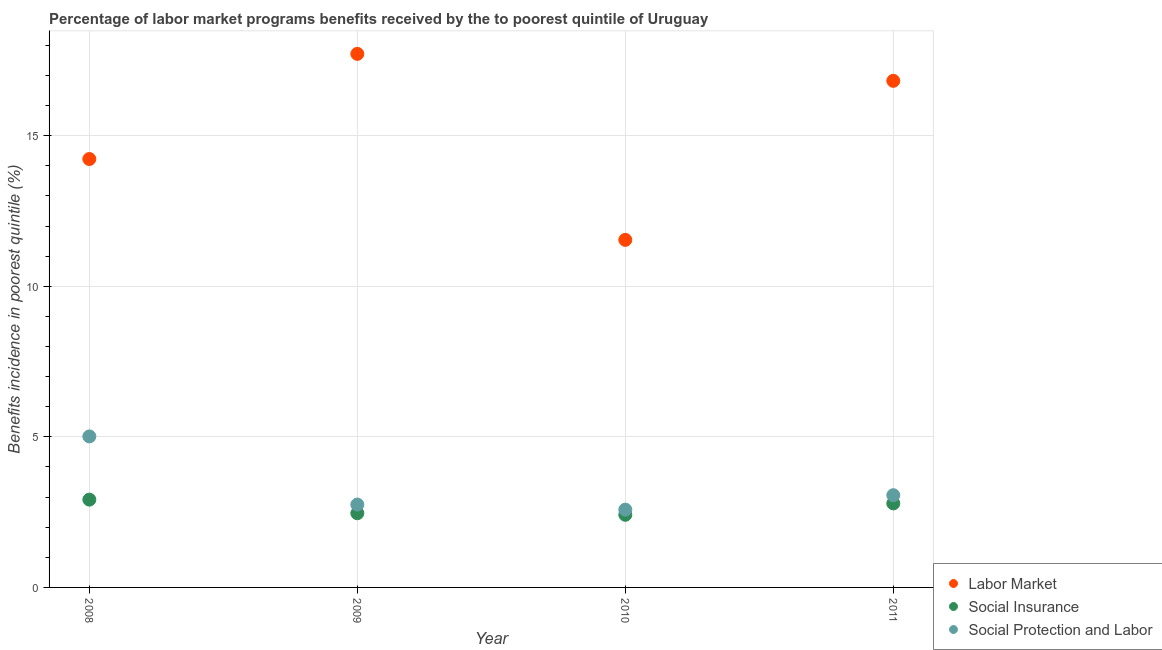How many different coloured dotlines are there?
Make the answer very short. 3. Is the number of dotlines equal to the number of legend labels?
Offer a terse response. Yes. What is the percentage of benefits received due to labor market programs in 2010?
Offer a terse response. 11.54. Across all years, what is the maximum percentage of benefits received due to social protection programs?
Your answer should be compact. 5.02. Across all years, what is the minimum percentage of benefits received due to social protection programs?
Offer a very short reply. 2.58. What is the total percentage of benefits received due to social protection programs in the graph?
Offer a very short reply. 13.41. What is the difference between the percentage of benefits received due to labor market programs in 2008 and that in 2010?
Your answer should be very brief. 2.68. What is the difference between the percentage of benefits received due to social insurance programs in 2010 and the percentage of benefits received due to social protection programs in 2009?
Your answer should be compact. -0.34. What is the average percentage of benefits received due to labor market programs per year?
Your response must be concise. 15.08. In the year 2011, what is the difference between the percentage of benefits received due to social insurance programs and percentage of benefits received due to social protection programs?
Your answer should be very brief. -0.27. In how many years, is the percentage of benefits received due to labor market programs greater than 4 %?
Your answer should be very brief. 4. What is the ratio of the percentage of benefits received due to social insurance programs in 2009 to that in 2010?
Keep it short and to the point. 1.02. Is the percentage of benefits received due to social protection programs in 2010 less than that in 2011?
Your answer should be compact. Yes. Is the difference between the percentage of benefits received due to social protection programs in 2008 and 2010 greater than the difference between the percentage of benefits received due to social insurance programs in 2008 and 2010?
Ensure brevity in your answer.  Yes. What is the difference between the highest and the second highest percentage of benefits received due to labor market programs?
Provide a short and direct response. 0.9. What is the difference between the highest and the lowest percentage of benefits received due to labor market programs?
Provide a succinct answer. 6.18. In how many years, is the percentage of benefits received due to labor market programs greater than the average percentage of benefits received due to labor market programs taken over all years?
Offer a terse response. 2. Is the sum of the percentage of benefits received due to social protection programs in 2008 and 2010 greater than the maximum percentage of benefits received due to labor market programs across all years?
Your response must be concise. No. Is it the case that in every year, the sum of the percentage of benefits received due to labor market programs and percentage of benefits received due to social insurance programs is greater than the percentage of benefits received due to social protection programs?
Your response must be concise. Yes. Is the percentage of benefits received due to social protection programs strictly greater than the percentage of benefits received due to social insurance programs over the years?
Make the answer very short. Yes. How many dotlines are there?
Your response must be concise. 3. How many years are there in the graph?
Your response must be concise. 4. Are the values on the major ticks of Y-axis written in scientific E-notation?
Make the answer very short. No. Does the graph contain grids?
Your answer should be very brief. Yes. Where does the legend appear in the graph?
Keep it short and to the point. Bottom right. How many legend labels are there?
Ensure brevity in your answer.  3. What is the title of the graph?
Your answer should be very brief. Percentage of labor market programs benefits received by the to poorest quintile of Uruguay. Does "Taxes on income" appear as one of the legend labels in the graph?
Provide a succinct answer. No. What is the label or title of the Y-axis?
Your answer should be compact. Benefits incidence in poorest quintile (%). What is the Benefits incidence in poorest quintile (%) of Labor Market in 2008?
Provide a succinct answer. 14.23. What is the Benefits incidence in poorest quintile (%) of Social Insurance in 2008?
Ensure brevity in your answer.  2.92. What is the Benefits incidence in poorest quintile (%) in Social Protection and Labor in 2008?
Offer a terse response. 5.02. What is the Benefits incidence in poorest quintile (%) of Labor Market in 2009?
Provide a short and direct response. 17.72. What is the Benefits incidence in poorest quintile (%) of Social Insurance in 2009?
Offer a terse response. 2.46. What is the Benefits incidence in poorest quintile (%) in Social Protection and Labor in 2009?
Your answer should be compact. 2.75. What is the Benefits incidence in poorest quintile (%) of Labor Market in 2010?
Offer a very short reply. 11.54. What is the Benefits incidence in poorest quintile (%) in Social Insurance in 2010?
Your answer should be very brief. 2.41. What is the Benefits incidence in poorest quintile (%) of Social Protection and Labor in 2010?
Your answer should be very brief. 2.58. What is the Benefits incidence in poorest quintile (%) of Labor Market in 2011?
Provide a succinct answer. 16.82. What is the Benefits incidence in poorest quintile (%) in Social Insurance in 2011?
Ensure brevity in your answer.  2.79. What is the Benefits incidence in poorest quintile (%) in Social Protection and Labor in 2011?
Keep it short and to the point. 3.06. Across all years, what is the maximum Benefits incidence in poorest quintile (%) of Labor Market?
Offer a terse response. 17.72. Across all years, what is the maximum Benefits incidence in poorest quintile (%) of Social Insurance?
Give a very brief answer. 2.92. Across all years, what is the maximum Benefits incidence in poorest quintile (%) in Social Protection and Labor?
Your answer should be very brief. 5.02. Across all years, what is the minimum Benefits incidence in poorest quintile (%) in Labor Market?
Offer a terse response. 11.54. Across all years, what is the minimum Benefits incidence in poorest quintile (%) of Social Insurance?
Make the answer very short. 2.41. Across all years, what is the minimum Benefits incidence in poorest quintile (%) in Social Protection and Labor?
Your answer should be compact. 2.58. What is the total Benefits incidence in poorest quintile (%) of Labor Market in the graph?
Your response must be concise. 60.32. What is the total Benefits incidence in poorest quintile (%) in Social Insurance in the graph?
Ensure brevity in your answer.  10.58. What is the total Benefits incidence in poorest quintile (%) in Social Protection and Labor in the graph?
Keep it short and to the point. 13.41. What is the difference between the Benefits incidence in poorest quintile (%) of Labor Market in 2008 and that in 2009?
Offer a very short reply. -3.49. What is the difference between the Benefits incidence in poorest quintile (%) of Social Insurance in 2008 and that in 2009?
Your answer should be compact. 0.45. What is the difference between the Benefits incidence in poorest quintile (%) of Social Protection and Labor in 2008 and that in 2009?
Offer a terse response. 2.26. What is the difference between the Benefits incidence in poorest quintile (%) in Labor Market in 2008 and that in 2010?
Your answer should be compact. 2.68. What is the difference between the Benefits incidence in poorest quintile (%) in Social Insurance in 2008 and that in 2010?
Your response must be concise. 0.5. What is the difference between the Benefits incidence in poorest quintile (%) in Social Protection and Labor in 2008 and that in 2010?
Your response must be concise. 2.43. What is the difference between the Benefits incidence in poorest quintile (%) in Labor Market in 2008 and that in 2011?
Give a very brief answer. -2.6. What is the difference between the Benefits incidence in poorest quintile (%) of Social Insurance in 2008 and that in 2011?
Your response must be concise. 0.13. What is the difference between the Benefits incidence in poorest quintile (%) of Social Protection and Labor in 2008 and that in 2011?
Offer a very short reply. 1.95. What is the difference between the Benefits incidence in poorest quintile (%) of Labor Market in 2009 and that in 2010?
Provide a succinct answer. 6.18. What is the difference between the Benefits incidence in poorest quintile (%) in Social Insurance in 2009 and that in 2010?
Ensure brevity in your answer.  0.05. What is the difference between the Benefits incidence in poorest quintile (%) in Social Protection and Labor in 2009 and that in 2010?
Your answer should be very brief. 0.17. What is the difference between the Benefits incidence in poorest quintile (%) in Labor Market in 2009 and that in 2011?
Give a very brief answer. 0.9. What is the difference between the Benefits incidence in poorest quintile (%) of Social Insurance in 2009 and that in 2011?
Your answer should be compact. -0.33. What is the difference between the Benefits incidence in poorest quintile (%) of Social Protection and Labor in 2009 and that in 2011?
Offer a terse response. -0.31. What is the difference between the Benefits incidence in poorest quintile (%) of Labor Market in 2010 and that in 2011?
Give a very brief answer. -5.28. What is the difference between the Benefits incidence in poorest quintile (%) in Social Insurance in 2010 and that in 2011?
Keep it short and to the point. -0.38. What is the difference between the Benefits incidence in poorest quintile (%) of Social Protection and Labor in 2010 and that in 2011?
Provide a short and direct response. -0.48. What is the difference between the Benefits incidence in poorest quintile (%) in Labor Market in 2008 and the Benefits incidence in poorest quintile (%) in Social Insurance in 2009?
Your answer should be compact. 11.76. What is the difference between the Benefits incidence in poorest quintile (%) in Labor Market in 2008 and the Benefits incidence in poorest quintile (%) in Social Protection and Labor in 2009?
Your answer should be very brief. 11.48. What is the difference between the Benefits incidence in poorest quintile (%) of Social Insurance in 2008 and the Benefits incidence in poorest quintile (%) of Social Protection and Labor in 2009?
Provide a short and direct response. 0.16. What is the difference between the Benefits incidence in poorest quintile (%) of Labor Market in 2008 and the Benefits incidence in poorest quintile (%) of Social Insurance in 2010?
Offer a very short reply. 11.82. What is the difference between the Benefits incidence in poorest quintile (%) of Labor Market in 2008 and the Benefits incidence in poorest quintile (%) of Social Protection and Labor in 2010?
Offer a terse response. 11.64. What is the difference between the Benefits incidence in poorest quintile (%) of Social Insurance in 2008 and the Benefits incidence in poorest quintile (%) of Social Protection and Labor in 2010?
Ensure brevity in your answer.  0.33. What is the difference between the Benefits incidence in poorest quintile (%) in Labor Market in 2008 and the Benefits incidence in poorest quintile (%) in Social Insurance in 2011?
Provide a succinct answer. 11.44. What is the difference between the Benefits incidence in poorest quintile (%) in Labor Market in 2008 and the Benefits incidence in poorest quintile (%) in Social Protection and Labor in 2011?
Provide a succinct answer. 11.17. What is the difference between the Benefits incidence in poorest quintile (%) in Social Insurance in 2008 and the Benefits incidence in poorest quintile (%) in Social Protection and Labor in 2011?
Give a very brief answer. -0.15. What is the difference between the Benefits incidence in poorest quintile (%) of Labor Market in 2009 and the Benefits incidence in poorest quintile (%) of Social Insurance in 2010?
Your answer should be compact. 15.31. What is the difference between the Benefits incidence in poorest quintile (%) of Labor Market in 2009 and the Benefits incidence in poorest quintile (%) of Social Protection and Labor in 2010?
Keep it short and to the point. 15.14. What is the difference between the Benefits incidence in poorest quintile (%) in Social Insurance in 2009 and the Benefits incidence in poorest quintile (%) in Social Protection and Labor in 2010?
Provide a short and direct response. -0.12. What is the difference between the Benefits incidence in poorest quintile (%) in Labor Market in 2009 and the Benefits incidence in poorest quintile (%) in Social Insurance in 2011?
Provide a short and direct response. 14.93. What is the difference between the Benefits incidence in poorest quintile (%) in Labor Market in 2009 and the Benefits incidence in poorest quintile (%) in Social Protection and Labor in 2011?
Your answer should be very brief. 14.66. What is the difference between the Benefits incidence in poorest quintile (%) in Social Insurance in 2009 and the Benefits incidence in poorest quintile (%) in Social Protection and Labor in 2011?
Offer a terse response. -0.6. What is the difference between the Benefits incidence in poorest quintile (%) in Labor Market in 2010 and the Benefits incidence in poorest quintile (%) in Social Insurance in 2011?
Provide a short and direct response. 8.75. What is the difference between the Benefits incidence in poorest quintile (%) of Labor Market in 2010 and the Benefits incidence in poorest quintile (%) of Social Protection and Labor in 2011?
Give a very brief answer. 8.48. What is the difference between the Benefits incidence in poorest quintile (%) of Social Insurance in 2010 and the Benefits incidence in poorest quintile (%) of Social Protection and Labor in 2011?
Ensure brevity in your answer.  -0.65. What is the average Benefits incidence in poorest quintile (%) of Labor Market per year?
Provide a short and direct response. 15.08. What is the average Benefits incidence in poorest quintile (%) in Social Insurance per year?
Your answer should be compact. 2.65. What is the average Benefits incidence in poorest quintile (%) of Social Protection and Labor per year?
Provide a succinct answer. 3.35. In the year 2008, what is the difference between the Benefits incidence in poorest quintile (%) of Labor Market and Benefits incidence in poorest quintile (%) of Social Insurance?
Ensure brevity in your answer.  11.31. In the year 2008, what is the difference between the Benefits incidence in poorest quintile (%) in Labor Market and Benefits incidence in poorest quintile (%) in Social Protection and Labor?
Keep it short and to the point. 9.21. In the year 2008, what is the difference between the Benefits incidence in poorest quintile (%) in Social Insurance and Benefits incidence in poorest quintile (%) in Social Protection and Labor?
Make the answer very short. -2.1. In the year 2009, what is the difference between the Benefits incidence in poorest quintile (%) of Labor Market and Benefits incidence in poorest quintile (%) of Social Insurance?
Ensure brevity in your answer.  15.26. In the year 2009, what is the difference between the Benefits incidence in poorest quintile (%) in Labor Market and Benefits incidence in poorest quintile (%) in Social Protection and Labor?
Keep it short and to the point. 14.97. In the year 2009, what is the difference between the Benefits incidence in poorest quintile (%) in Social Insurance and Benefits incidence in poorest quintile (%) in Social Protection and Labor?
Your answer should be compact. -0.29. In the year 2010, what is the difference between the Benefits incidence in poorest quintile (%) in Labor Market and Benefits incidence in poorest quintile (%) in Social Insurance?
Your answer should be very brief. 9.13. In the year 2010, what is the difference between the Benefits incidence in poorest quintile (%) in Labor Market and Benefits incidence in poorest quintile (%) in Social Protection and Labor?
Your response must be concise. 8.96. In the year 2010, what is the difference between the Benefits incidence in poorest quintile (%) in Social Insurance and Benefits incidence in poorest quintile (%) in Social Protection and Labor?
Ensure brevity in your answer.  -0.17. In the year 2011, what is the difference between the Benefits incidence in poorest quintile (%) in Labor Market and Benefits incidence in poorest quintile (%) in Social Insurance?
Your response must be concise. 14.03. In the year 2011, what is the difference between the Benefits incidence in poorest quintile (%) of Labor Market and Benefits incidence in poorest quintile (%) of Social Protection and Labor?
Your answer should be very brief. 13.76. In the year 2011, what is the difference between the Benefits incidence in poorest quintile (%) of Social Insurance and Benefits incidence in poorest quintile (%) of Social Protection and Labor?
Your answer should be very brief. -0.27. What is the ratio of the Benefits incidence in poorest quintile (%) in Labor Market in 2008 to that in 2009?
Make the answer very short. 0.8. What is the ratio of the Benefits incidence in poorest quintile (%) of Social Insurance in 2008 to that in 2009?
Offer a very short reply. 1.18. What is the ratio of the Benefits incidence in poorest quintile (%) in Social Protection and Labor in 2008 to that in 2009?
Keep it short and to the point. 1.82. What is the ratio of the Benefits incidence in poorest quintile (%) in Labor Market in 2008 to that in 2010?
Give a very brief answer. 1.23. What is the ratio of the Benefits incidence in poorest quintile (%) of Social Insurance in 2008 to that in 2010?
Provide a succinct answer. 1.21. What is the ratio of the Benefits incidence in poorest quintile (%) of Social Protection and Labor in 2008 to that in 2010?
Your response must be concise. 1.94. What is the ratio of the Benefits incidence in poorest quintile (%) in Labor Market in 2008 to that in 2011?
Provide a succinct answer. 0.85. What is the ratio of the Benefits incidence in poorest quintile (%) of Social Insurance in 2008 to that in 2011?
Provide a succinct answer. 1.05. What is the ratio of the Benefits incidence in poorest quintile (%) of Social Protection and Labor in 2008 to that in 2011?
Your answer should be very brief. 1.64. What is the ratio of the Benefits incidence in poorest quintile (%) of Labor Market in 2009 to that in 2010?
Provide a short and direct response. 1.54. What is the ratio of the Benefits incidence in poorest quintile (%) in Social Insurance in 2009 to that in 2010?
Your response must be concise. 1.02. What is the ratio of the Benefits incidence in poorest quintile (%) of Social Protection and Labor in 2009 to that in 2010?
Provide a succinct answer. 1.07. What is the ratio of the Benefits incidence in poorest quintile (%) of Labor Market in 2009 to that in 2011?
Offer a very short reply. 1.05. What is the ratio of the Benefits incidence in poorest quintile (%) of Social Insurance in 2009 to that in 2011?
Keep it short and to the point. 0.88. What is the ratio of the Benefits incidence in poorest quintile (%) in Social Protection and Labor in 2009 to that in 2011?
Provide a short and direct response. 0.9. What is the ratio of the Benefits incidence in poorest quintile (%) in Labor Market in 2010 to that in 2011?
Offer a terse response. 0.69. What is the ratio of the Benefits incidence in poorest quintile (%) of Social Insurance in 2010 to that in 2011?
Your answer should be very brief. 0.86. What is the ratio of the Benefits incidence in poorest quintile (%) in Social Protection and Labor in 2010 to that in 2011?
Make the answer very short. 0.84. What is the difference between the highest and the second highest Benefits incidence in poorest quintile (%) in Labor Market?
Offer a terse response. 0.9. What is the difference between the highest and the second highest Benefits incidence in poorest quintile (%) in Social Insurance?
Keep it short and to the point. 0.13. What is the difference between the highest and the second highest Benefits incidence in poorest quintile (%) of Social Protection and Labor?
Your answer should be very brief. 1.95. What is the difference between the highest and the lowest Benefits incidence in poorest quintile (%) in Labor Market?
Provide a short and direct response. 6.18. What is the difference between the highest and the lowest Benefits incidence in poorest quintile (%) in Social Insurance?
Keep it short and to the point. 0.5. What is the difference between the highest and the lowest Benefits incidence in poorest quintile (%) of Social Protection and Labor?
Your answer should be very brief. 2.43. 